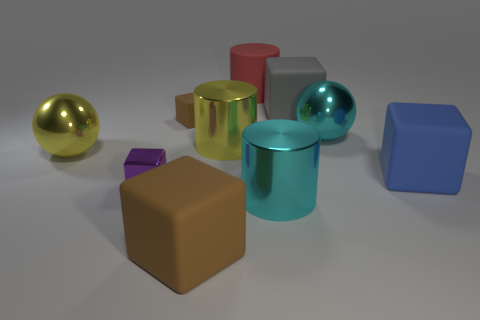Subtract all yellow cylinders. How many brown cubes are left? 2 Subtract all gray rubber blocks. How many blocks are left? 4 Subtract 1 blocks. How many blocks are left? 4 Add 5 cyan objects. How many cyan objects are left? 7 Add 6 red cylinders. How many red cylinders exist? 7 Subtract all blue cubes. How many cubes are left? 4 Subtract 0 blue cylinders. How many objects are left? 10 Subtract all cylinders. How many objects are left? 7 Subtract all red cylinders. Subtract all purple blocks. How many cylinders are left? 2 Subtract all big yellow things. Subtract all brown rubber cubes. How many objects are left? 6 